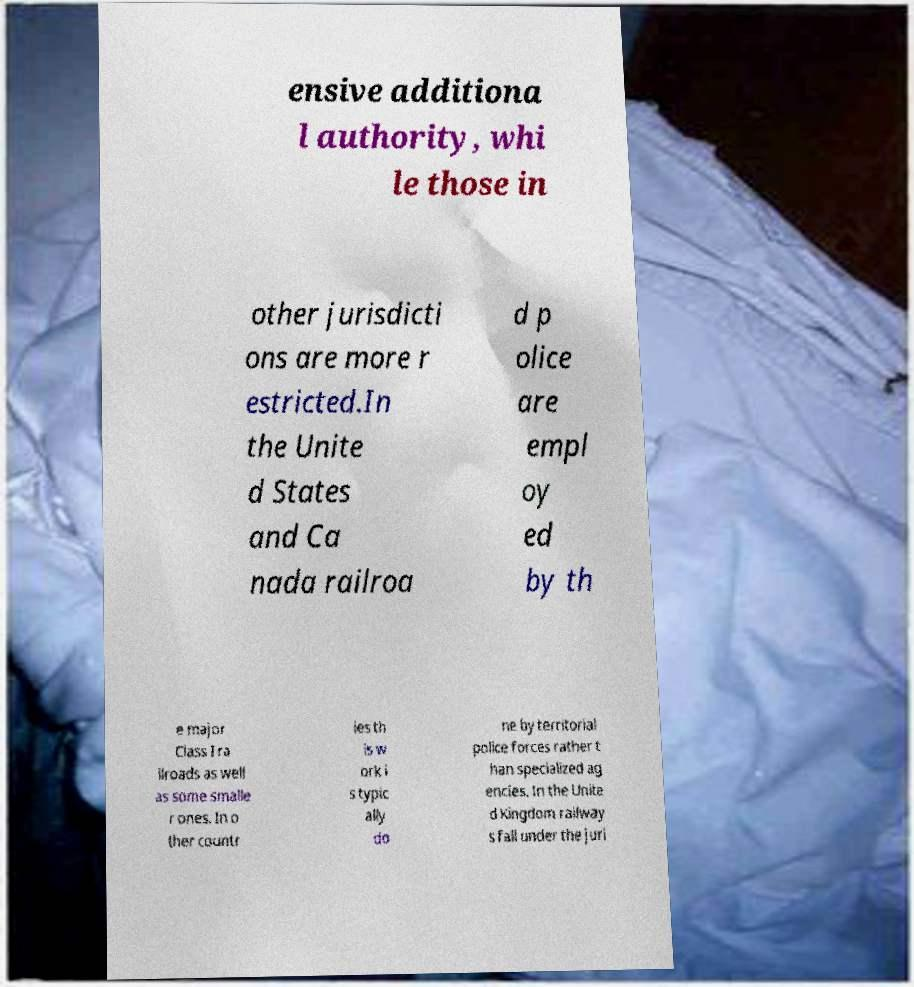Can you accurately transcribe the text from the provided image for me? ensive additiona l authority, whi le those in other jurisdicti ons are more r estricted.In the Unite d States and Ca nada railroa d p olice are empl oy ed by th e major Class I ra ilroads as well as some smalle r ones. In o ther countr ies th is w ork i s typic ally do ne by territorial police forces rather t han specialized ag encies. In the Unite d Kingdom railway s fall under the juri 